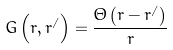Convert formula to latex. <formula><loc_0><loc_0><loc_500><loc_500>G \left ( r , r ^ { / } \right ) = \frac { \Theta \left ( r - r ^ { / } \right ) } { r }</formula> 